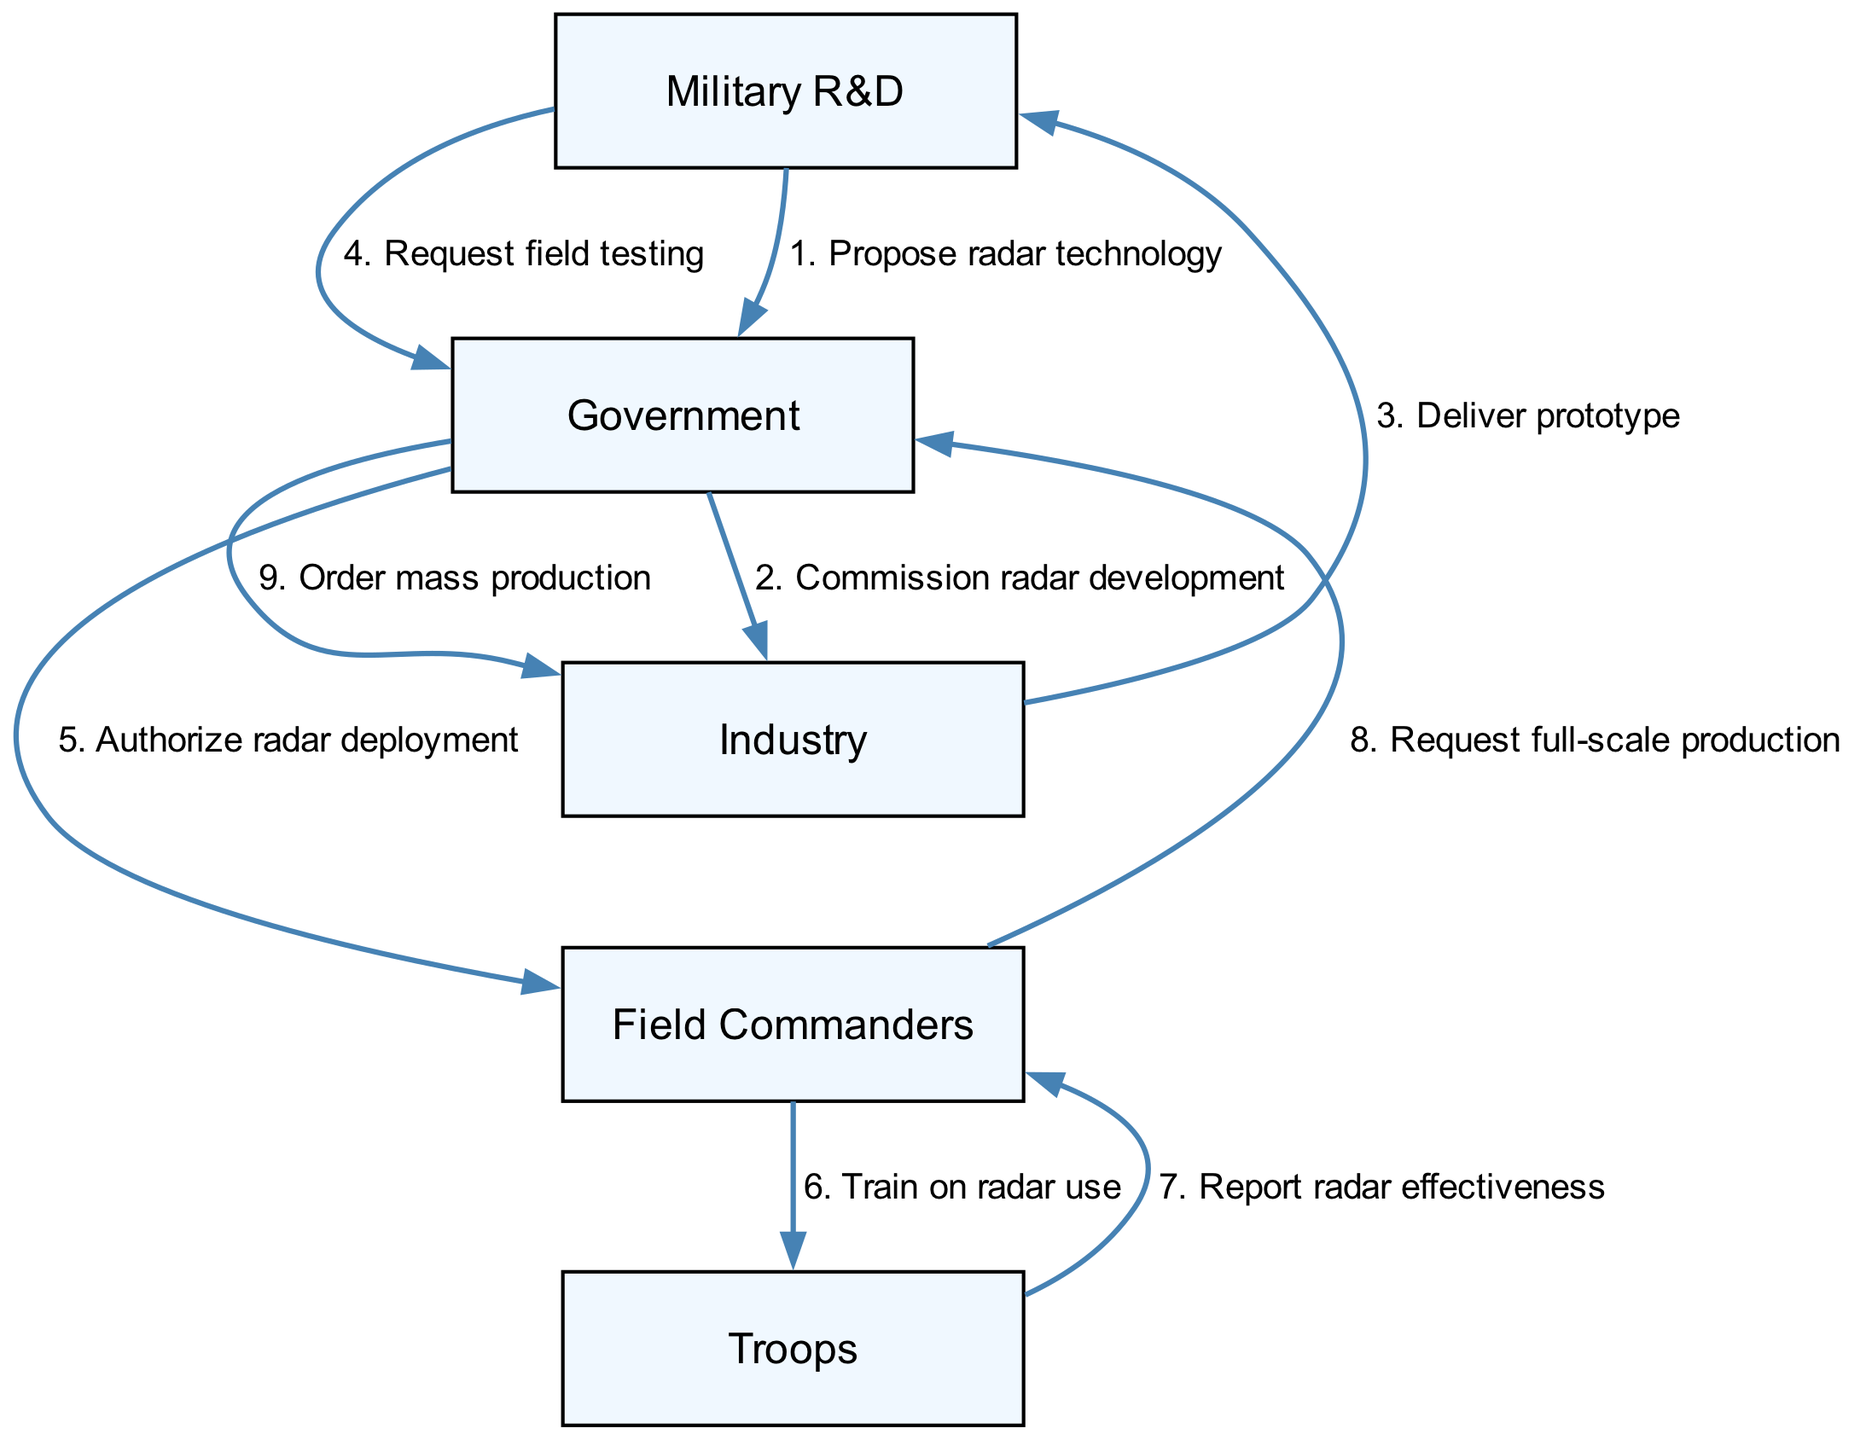What is the first step in the sequence? The diagram starts with the Military R&D proposing radar technology to the Government. This is the first interaction in the sequence of events.
Answer: Propose radar technology Who receives the prototype? The prototype is delivered from Industry to Military R&D, as indicated by the flow of information from one participant to the other.
Answer: Military R&D How many participants are involved in this diagram? The diagram lists five participants: Military R&D, Government, Industry, Field Commanders, and Troops. Counting these gives a total of five participants.
Answer: Five What does the Government authorize after receiving a request? The Government authorizes the deployment of radar technology after receiving a request from the Military R&D to conduct field testing. This is indicated in the flow between the Government and Field Commanders.
Answer: Authorize radar deployment What action follows the training of Troops? After the Troops are trained on radar use, they report radar effectiveness back to Field Commanders, indicating a feedback loop in the deployment process.
Answer: Report radar effectiveness Which participant requests full-scale production? Field Commanders request full-scale production after they have received effectiveness reports from Troops, which indicates they have assessed the technology's utility in the field.
Answer: Field Commanders What action does the Government take in response to the request for mass production? Upon receiving the request for full-scale production from Field Commanders, the Government orders mass production from Industry, illustrating a direct action in response to the findings on radar effectiveness.
Answer: Order mass production How many total messages are exchanged in the sequence? By counting the exchanges between the participants, there are a total of nine messages communicated through the sequence of events.
Answer: Nine 